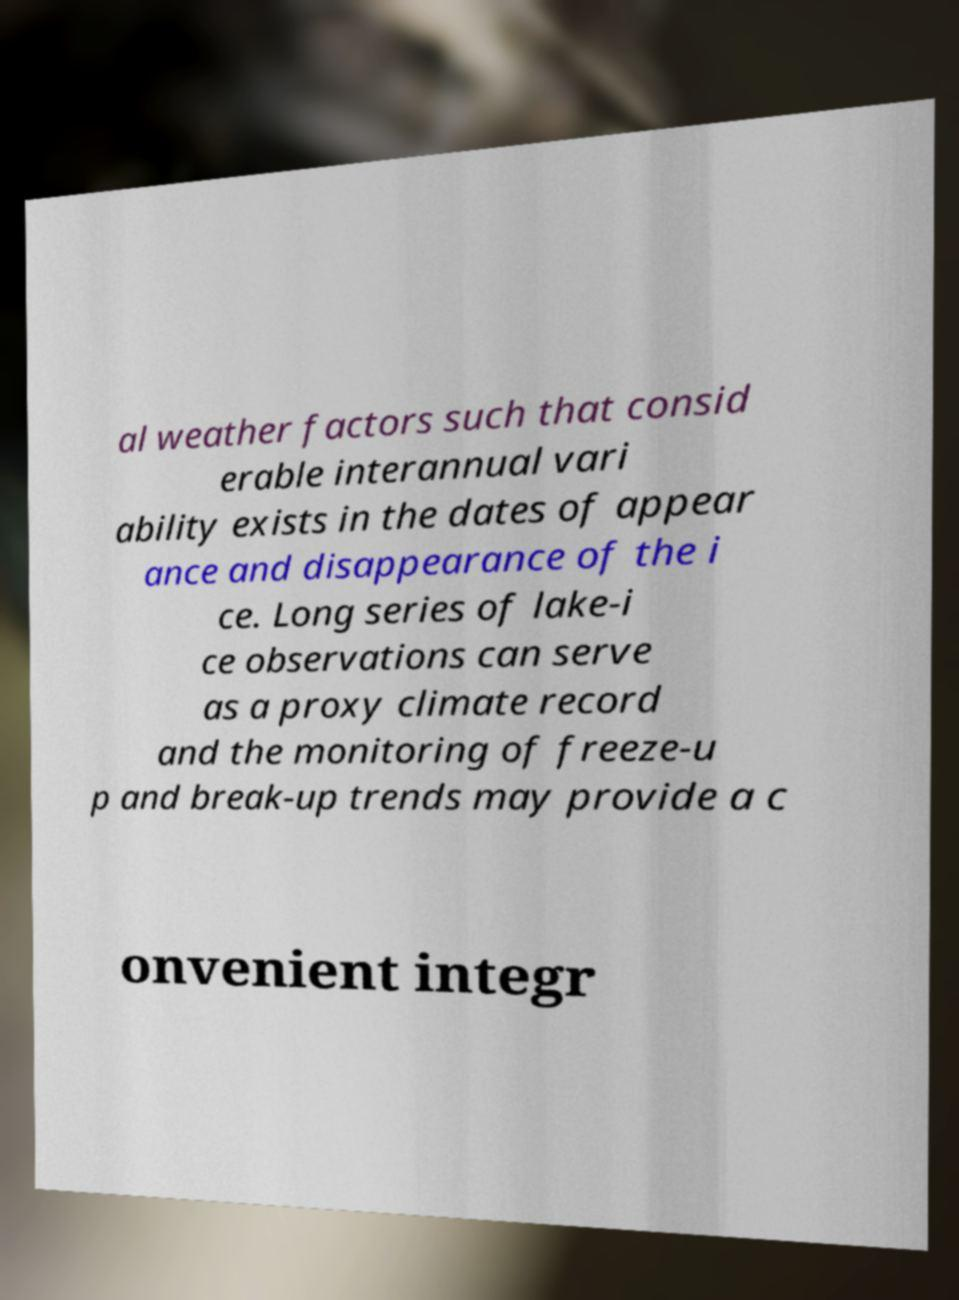Could you assist in decoding the text presented in this image and type it out clearly? al weather factors such that consid erable interannual vari ability exists in the dates of appear ance and disappearance of the i ce. Long series of lake-i ce observations can serve as a proxy climate record and the monitoring of freeze-u p and break-up trends may provide a c onvenient integr 